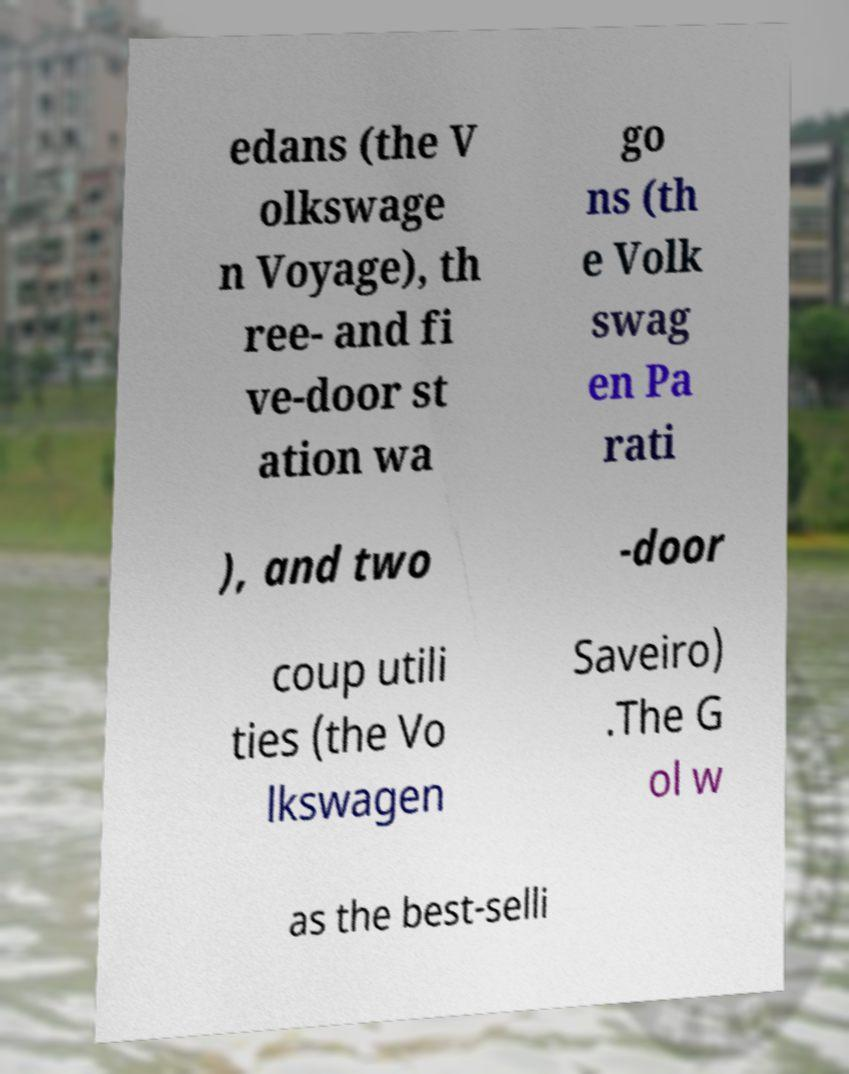For documentation purposes, I need the text within this image transcribed. Could you provide that? edans (the V olkswage n Voyage), th ree- and fi ve-door st ation wa go ns (th e Volk swag en Pa rati ), and two -door coup utili ties (the Vo lkswagen Saveiro) .The G ol w as the best-selli 